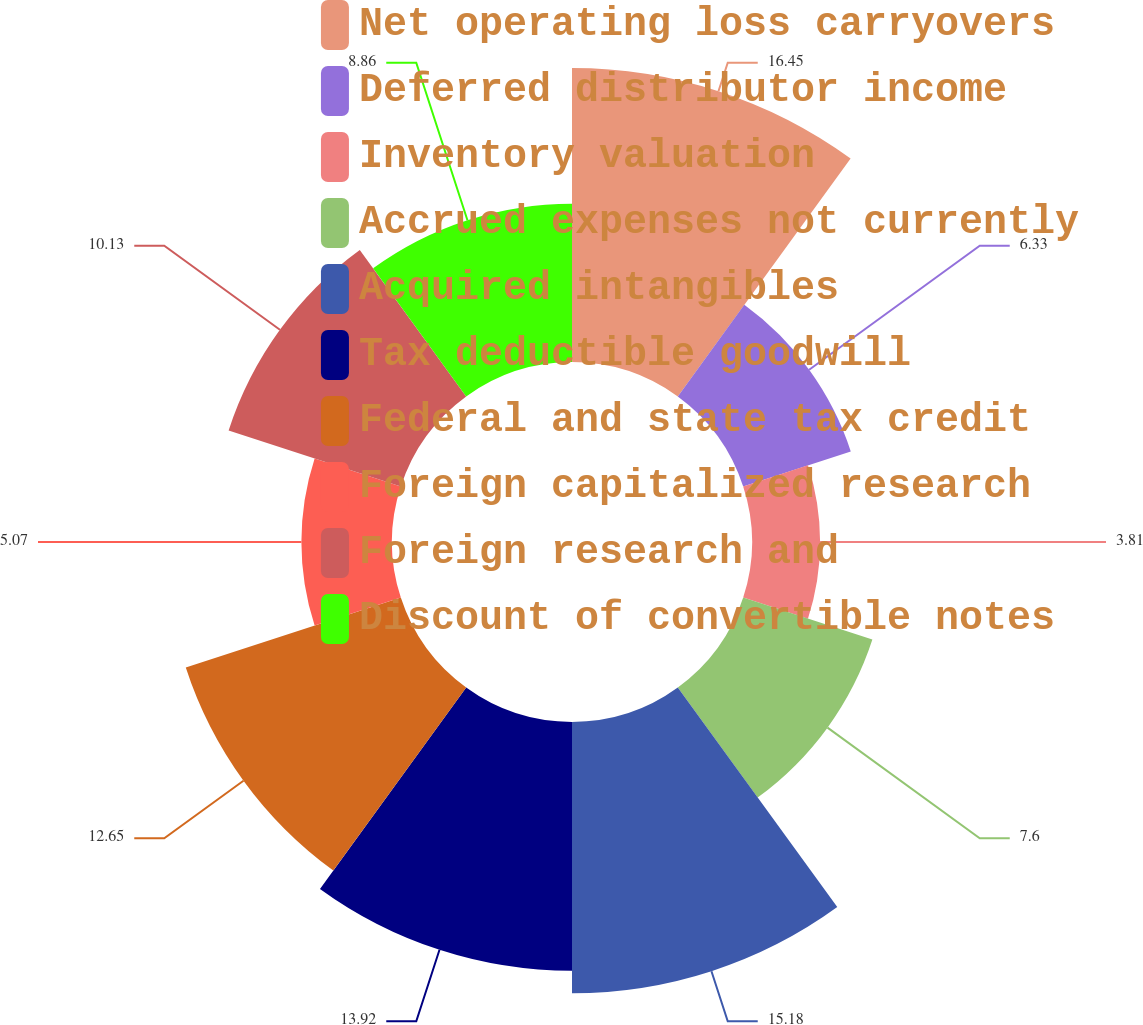<chart> <loc_0><loc_0><loc_500><loc_500><pie_chart><fcel>Net operating loss carryovers<fcel>Deferred distributor income<fcel>Inventory valuation<fcel>Accrued expenses not currently<fcel>Acquired intangibles<fcel>Tax deductible goodwill<fcel>Federal and state tax credit<fcel>Foreign capitalized research<fcel>Foreign research and<fcel>Discount of convertible notes<nl><fcel>16.45%<fcel>6.33%<fcel>3.81%<fcel>7.6%<fcel>15.18%<fcel>13.92%<fcel>12.65%<fcel>5.07%<fcel>10.13%<fcel>8.86%<nl></chart> 